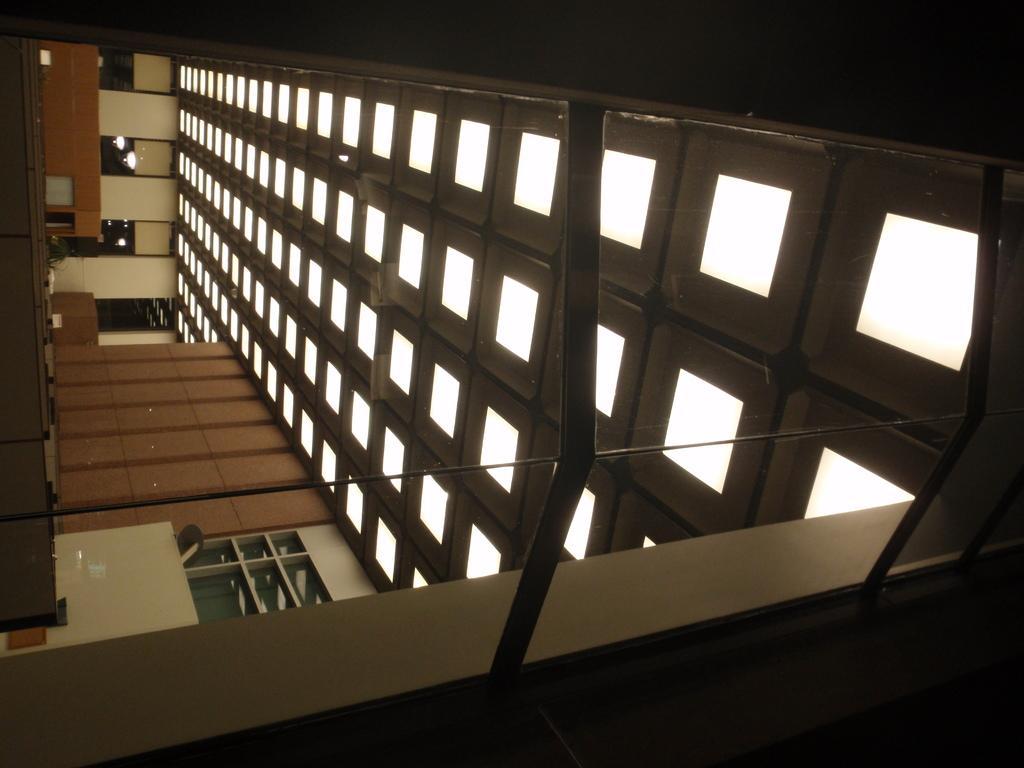Please provide a concise description of this image. In this image we can see the interior of a building, which consists of windows and there are lights in the ceiling. 